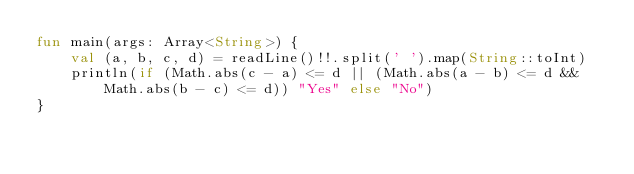Convert code to text. <code><loc_0><loc_0><loc_500><loc_500><_Kotlin_>fun main(args: Array<String>) {
    val (a, b, c, d) = readLine()!!.split(' ').map(String::toInt)
    println(if (Math.abs(c - a) <= d || (Math.abs(a - b) <= d && Math.abs(b - c) <= d)) "Yes" else "No")
}
</code> 